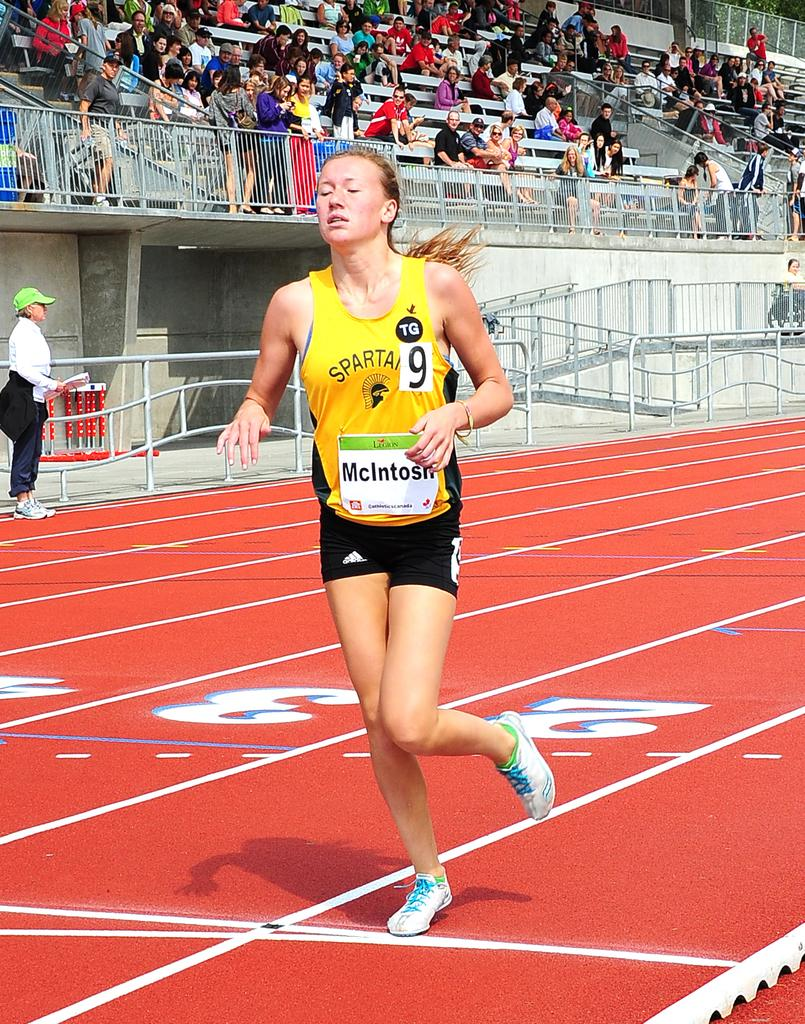What type of location is depicted in the image? The image appears to be a stadium. Are there any people present in the image? Yes, there are people in the image. What is one person doing in the image? One person is running on the ground. What type of structures can be seen in the image? There are railings and benches in the image. What type of plot is the woman weaving in the image? There is no woman or weaving activity present in the image. 